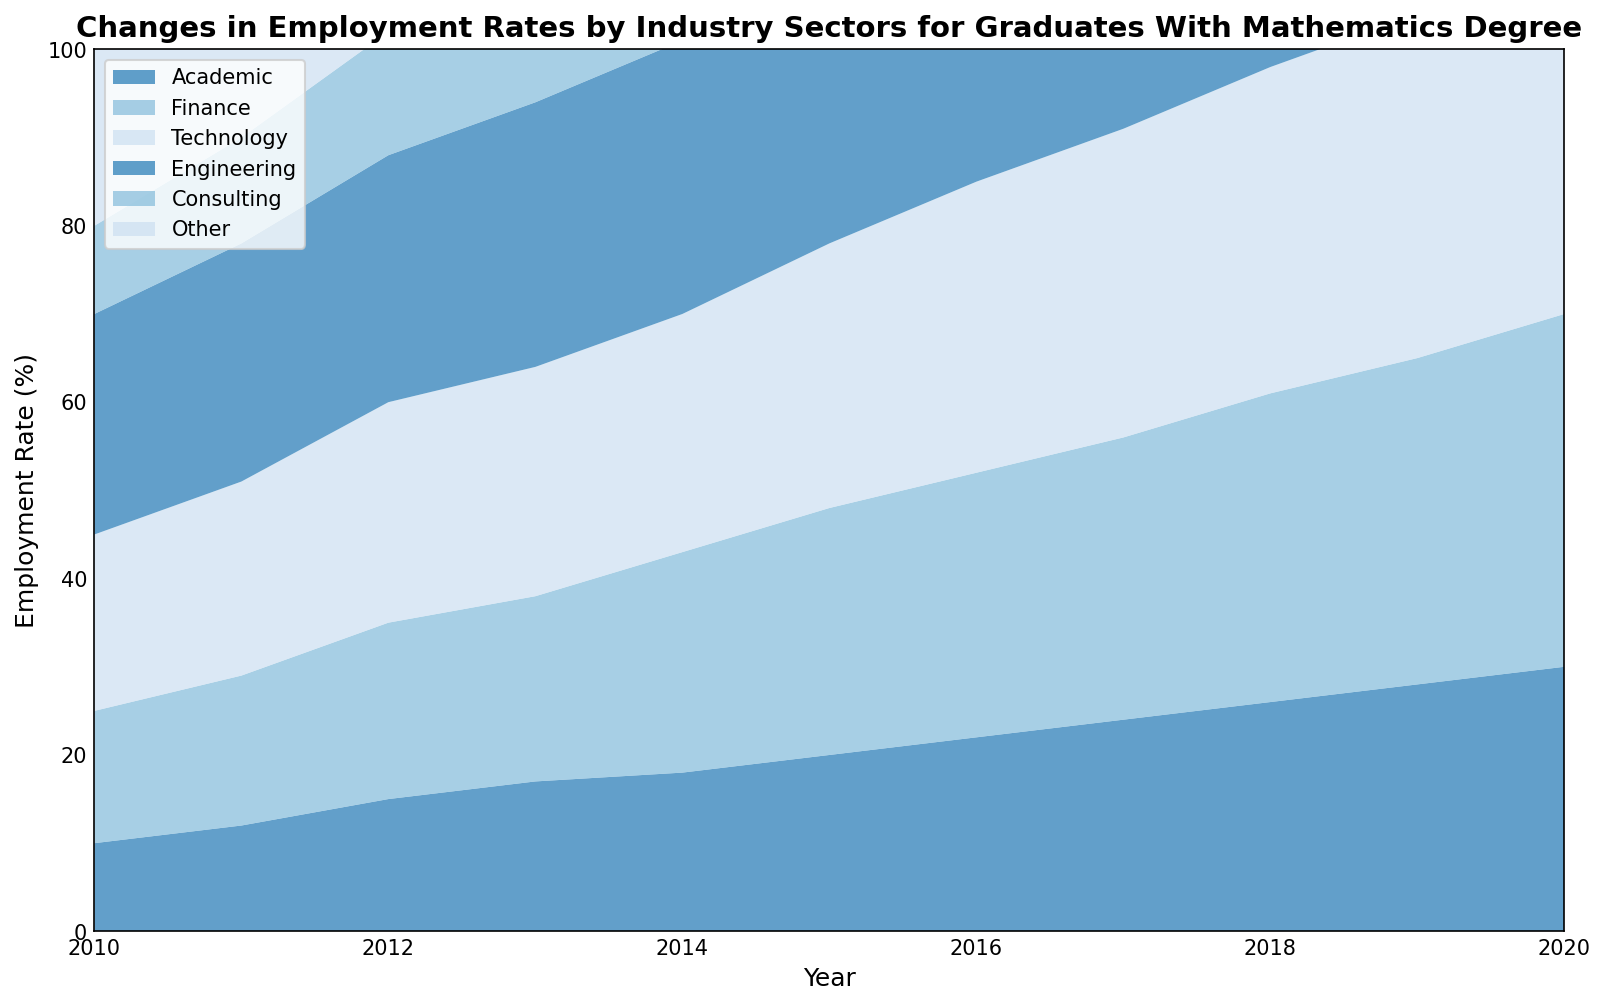Which industry sector had the highest employment rate for graduates with mathematics degrees in 2020? Looking at the end of the chart for 2020, the Technology sector appears to have the tallest area indicating the highest employment rate.
Answer: Technology Comparing the Finance and Consulting sectors in 2014, which had a higher employment rate? In 2014, the Finance sector is visually higher in the area chart compared to the Consulting sector.
Answer: Finance What was the general trend in employment rates for the Engineering sector from 2010 to 2020? The area representing the Engineering sector shows a consistent upward trend from 2010 to 2020, indicating a steady increase in employment rates.
Answer: Increasing Which year did the Academic sector experience the highest growth rate compared to the previous year? Observing the slopes in the Academic area, the steepest increase appears between 2012 and 2013.
Answer: 2013 What is the difference in employment rates between the Technology and Academic sectors in 2019? In 2019, the Technology sector stands at approximately 39%, and the Academic sector is at about 28%. The difference is 39% - 28% = 11%.
Answer: 11% In which year did the Consulting sector reach an employment rate of 28%? The chart indicates that the Consulting sector reached approximately 28% in 2020.
Answer: 2020 Which sector showed the least change in employment rates over the given years? By examining the consistency of the area sizes over the years, the Other sector seems to have the least variation, indicating minimal changes.
Answer: Other How much did the employment rate in the Finance sector increase from 2015 to 2020? In 2015, the Finance sector was at 28%. By 2020, it increased to 40%. The increase is 40% - 28% = 12%.
Answer: 12% On average, which sector had the highest employment rate growth per year between 2010 and 2020? The Technology sector appears to have the most consistent and steep upward trend. Calculating the average increase per year from 20% in 2010 to 42% in 2020, (42% - 20%) / 10 years = 2.2% per year.
Answer: Technology In 2018, which two sectors were closest in employment rates? In 2018, the chart shows that the Consulting sector (24%) and the Technology sector (25%) had the closest employment rates.
Answer: Consulting and Technology 